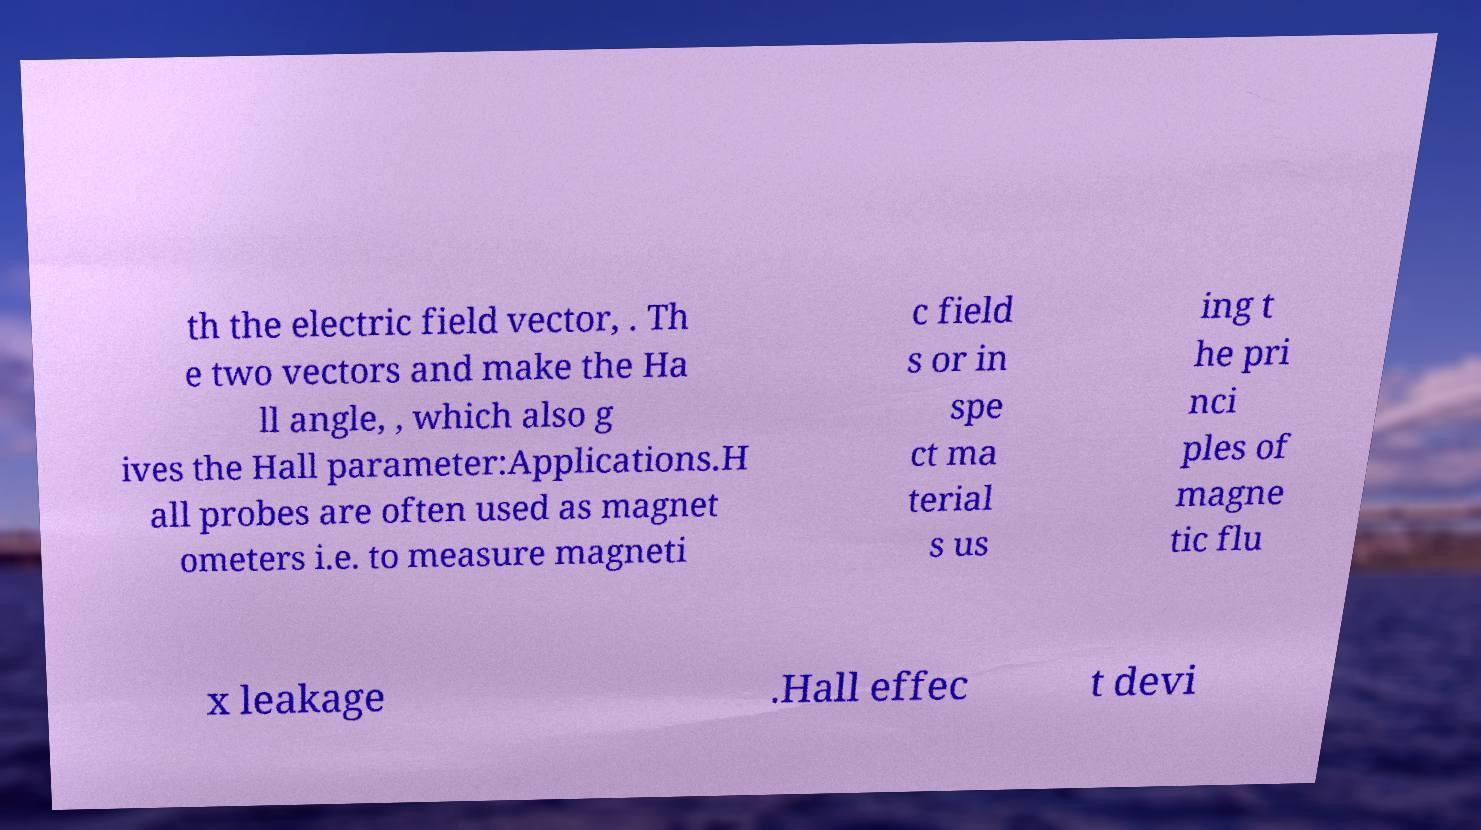I need the written content from this picture converted into text. Can you do that? th the electric field vector, . Th e two vectors and make the Ha ll angle, , which also g ives the Hall parameter:Applications.H all probes are often used as magnet ometers i.e. to measure magneti c field s or in spe ct ma terial s us ing t he pri nci ples of magne tic flu x leakage .Hall effec t devi 